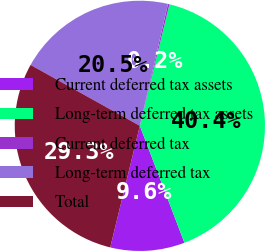<chart> <loc_0><loc_0><loc_500><loc_500><pie_chart><fcel>Current deferred tax assets<fcel>Long-term deferred tax assets<fcel>Current deferred tax<fcel>Long-term deferred tax<fcel>Total<nl><fcel>9.6%<fcel>40.4%<fcel>0.2%<fcel>20.51%<fcel>29.29%<nl></chart> 